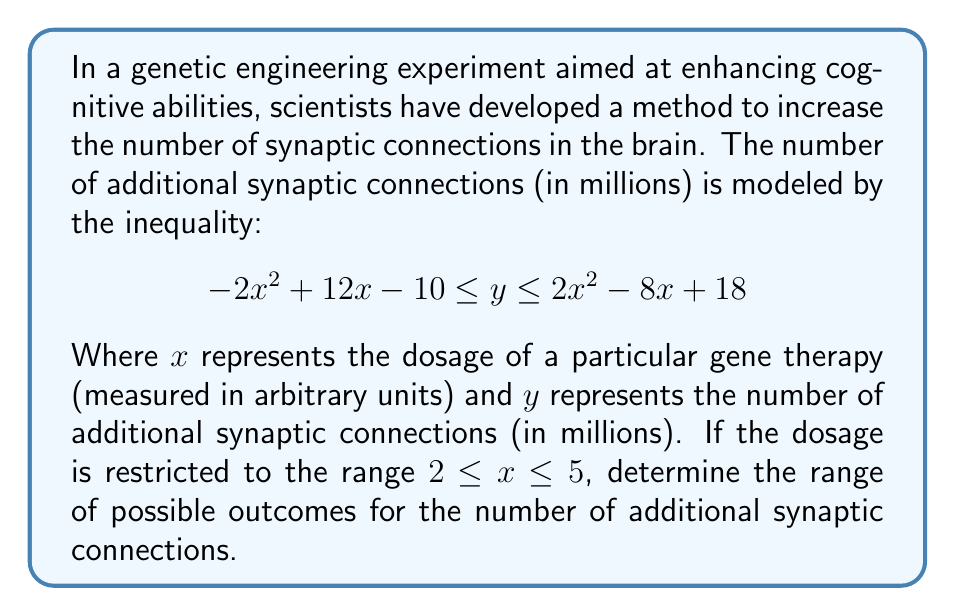Can you solve this math problem? To solve this problem, we need to find the minimum and maximum values of $y$ within the given range of $x$. Let's approach this step-by-step:

1) First, let's consider the lower bound: $-2x^2 + 12x - 10$
   
   To find the maximum of this parabola:
   $$\frac{d}{dx}(-2x^2 + 12x - 10) = -4x + 12 = 0$$
   $$x = 3$$
   
   This critical point is within our range of $2 \leq x \leq 5$.

2) Now, let's consider the upper bound: $2x^2 - 8x + 18$
   
   To find the minimum of this parabola:
   $$\frac{d}{dx}(2x^2 - 8x + 18) = 4x - 8 = 0$$
   $$x = 2$$
   
   This critical point is at the lower end of our range.

3) Let's evaluate both functions at $x = 2$, $x = 3$, and $x = 5$ (the critical points and endpoints):

   At $x = 2$:
   Lower bound: $-2(2)^2 + 12(2) - 10 = 6$
   Upper bound: $2(2)^2 - 8(2) + 18 = 14$

   At $x = 3$:
   Lower bound: $-2(3)^2 + 12(3) - 10 = 8$
   Upper bound: $2(3)^2 - 8(3) + 18 = 18$

   At $x = 5$:
   Lower bound: $-2(5)^2 + 12(5) - 10 = -10$
   Upper bound: $2(5)^2 - 8(5) + 18 = 38$

4) The minimum value of $y$ is the smallest value of the lower bound: $-10$ (at $x = 5$)
   The maximum value of $y$ is the largest value of the upper bound: $38$ (at $x = 5$)

Therefore, the range of possible outcomes for the number of additional synaptic connections is $-10 \leq y \leq 38$ million.
Answer: The range of possible outcomes for the number of additional synaptic connections is $[-10, 38]$ million. 